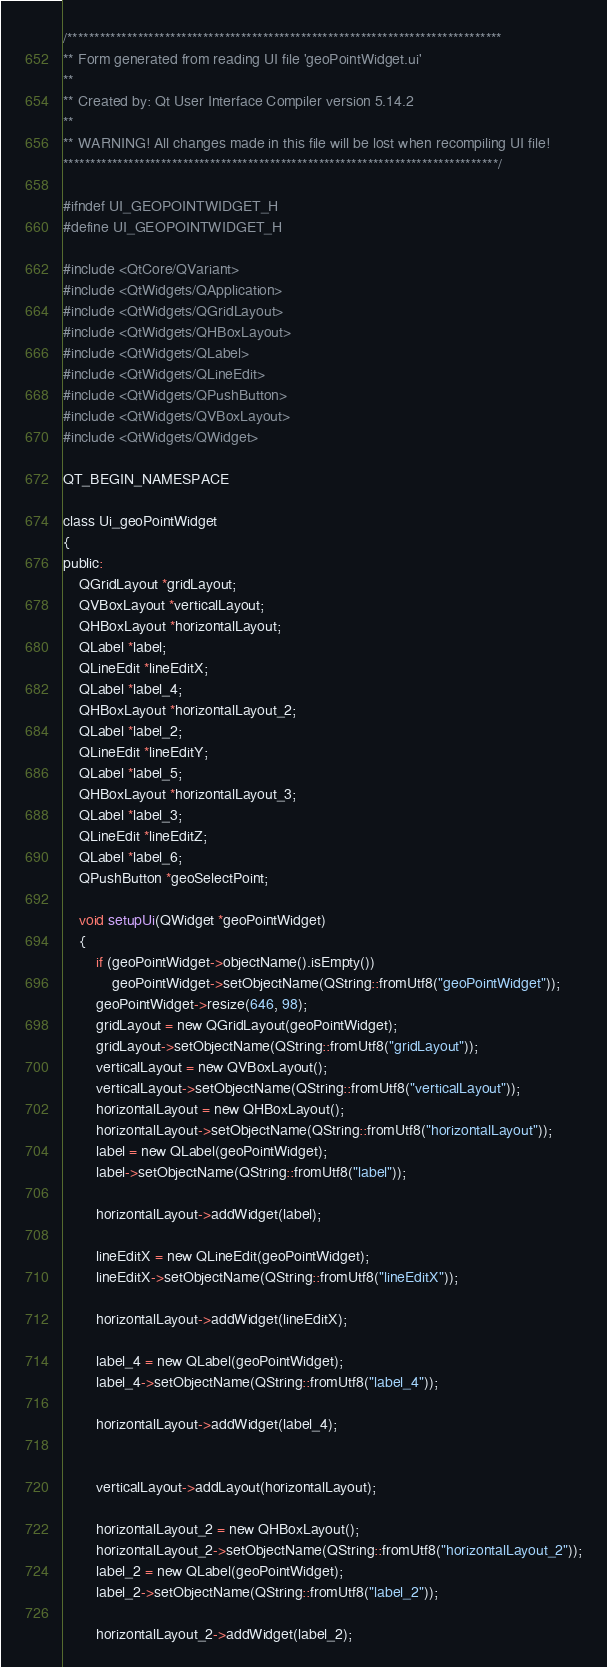Convert code to text. <code><loc_0><loc_0><loc_500><loc_500><_C_>/********************************************************************************
** Form generated from reading UI file 'geoPointWidget.ui'
**
** Created by: Qt User Interface Compiler version 5.14.2
**
** WARNING! All changes made in this file will be lost when recompiling UI file!
********************************************************************************/

#ifndef UI_GEOPOINTWIDGET_H
#define UI_GEOPOINTWIDGET_H

#include <QtCore/QVariant>
#include <QtWidgets/QApplication>
#include <QtWidgets/QGridLayout>
#include <QtWidgets/QHBoxLayout>
#include <QtWidgets/QLabel>
#include <QtWidgets/QLineEdit>
#include <QtWidgets/QPushButton>
#include <QtWidgets/QVBoxLayout>
#include <QtWidgets/QWidget>

QT_BEGIN_NAMESPACE

class Ui_geoPointWidget
{
public:
    QGridLayout *gridLayout;
    QVBoxLayout *verticalLayout;
    QHBoxLayout *horizontalLayout;
    QLabel *label;
    QLineEdit *lineEditX;
    QLabel *label_4;
    QHBoxLayout *horizontalLayout_2;
    QLabel *label_2;
    QLineEdit *lineEditY;
    QLabel *label_5;
    QHBoxLayout *horizontalLayout_3;
    QLabel *label_3;
    QLineEdit *lineEditZ;
    QLabel *label_6;
    QPushButton *geoSelectPoint;

    void setupUi(QWidget *geoPointWidget)
    {
        if (geoPointWidget->objectName().isEmpty())
            geoPointWidget->setObjectName(QString::fromUtf8("geoPointWidget"));
        geoPointWidget->resize(646, 98);
        gridLayout = new QGridLayout(geoPointWidget);
        gridLayout->setObjectName(QString::fromUtf8("gridLayout"));
        verticalLayout = new QVBoxLayout();
        verticalLayout->setObjectName(QString::fromUtf8("verticalLayout"));
        horizontalLayout = new QHBoxLayout();
        horizontalLayout->setObjectName(QString::fromUtf8("horizontalLayout"));
        label = new QLabel(geoPointWidget);
        label->setObjectName(QString::fromUtf8("label"));

        horizontalLayout->addWidget(label);

        lineEditX = new QLineEdit(geoPointWidget);
        lineEditX->setObjectName(QString::fromUtf8("lineEditX"));

        horizontalLayout->addWidget(lineEditX);

        label_4 = new QLabel(geoPointWidget);
        label_4->setObjectName(QString::fromUtf8("label_4"));

        horizontalLayout->addWidget(label_4);


        verticalLayout->addLayout(horizontalLayout);

        horizontalLayout_2 = new QHBoxLayout();
        horizontalLayout_2->setObjectName(QString::fromUtf8("horizontalLayout_2"));
        label_2 = new QLabel(geoPointWidget);
        label_2->setObjectName(QString::fromUtf8("label_2"));

        horizontalLayout_2->addWidget(label_2);
</code> 